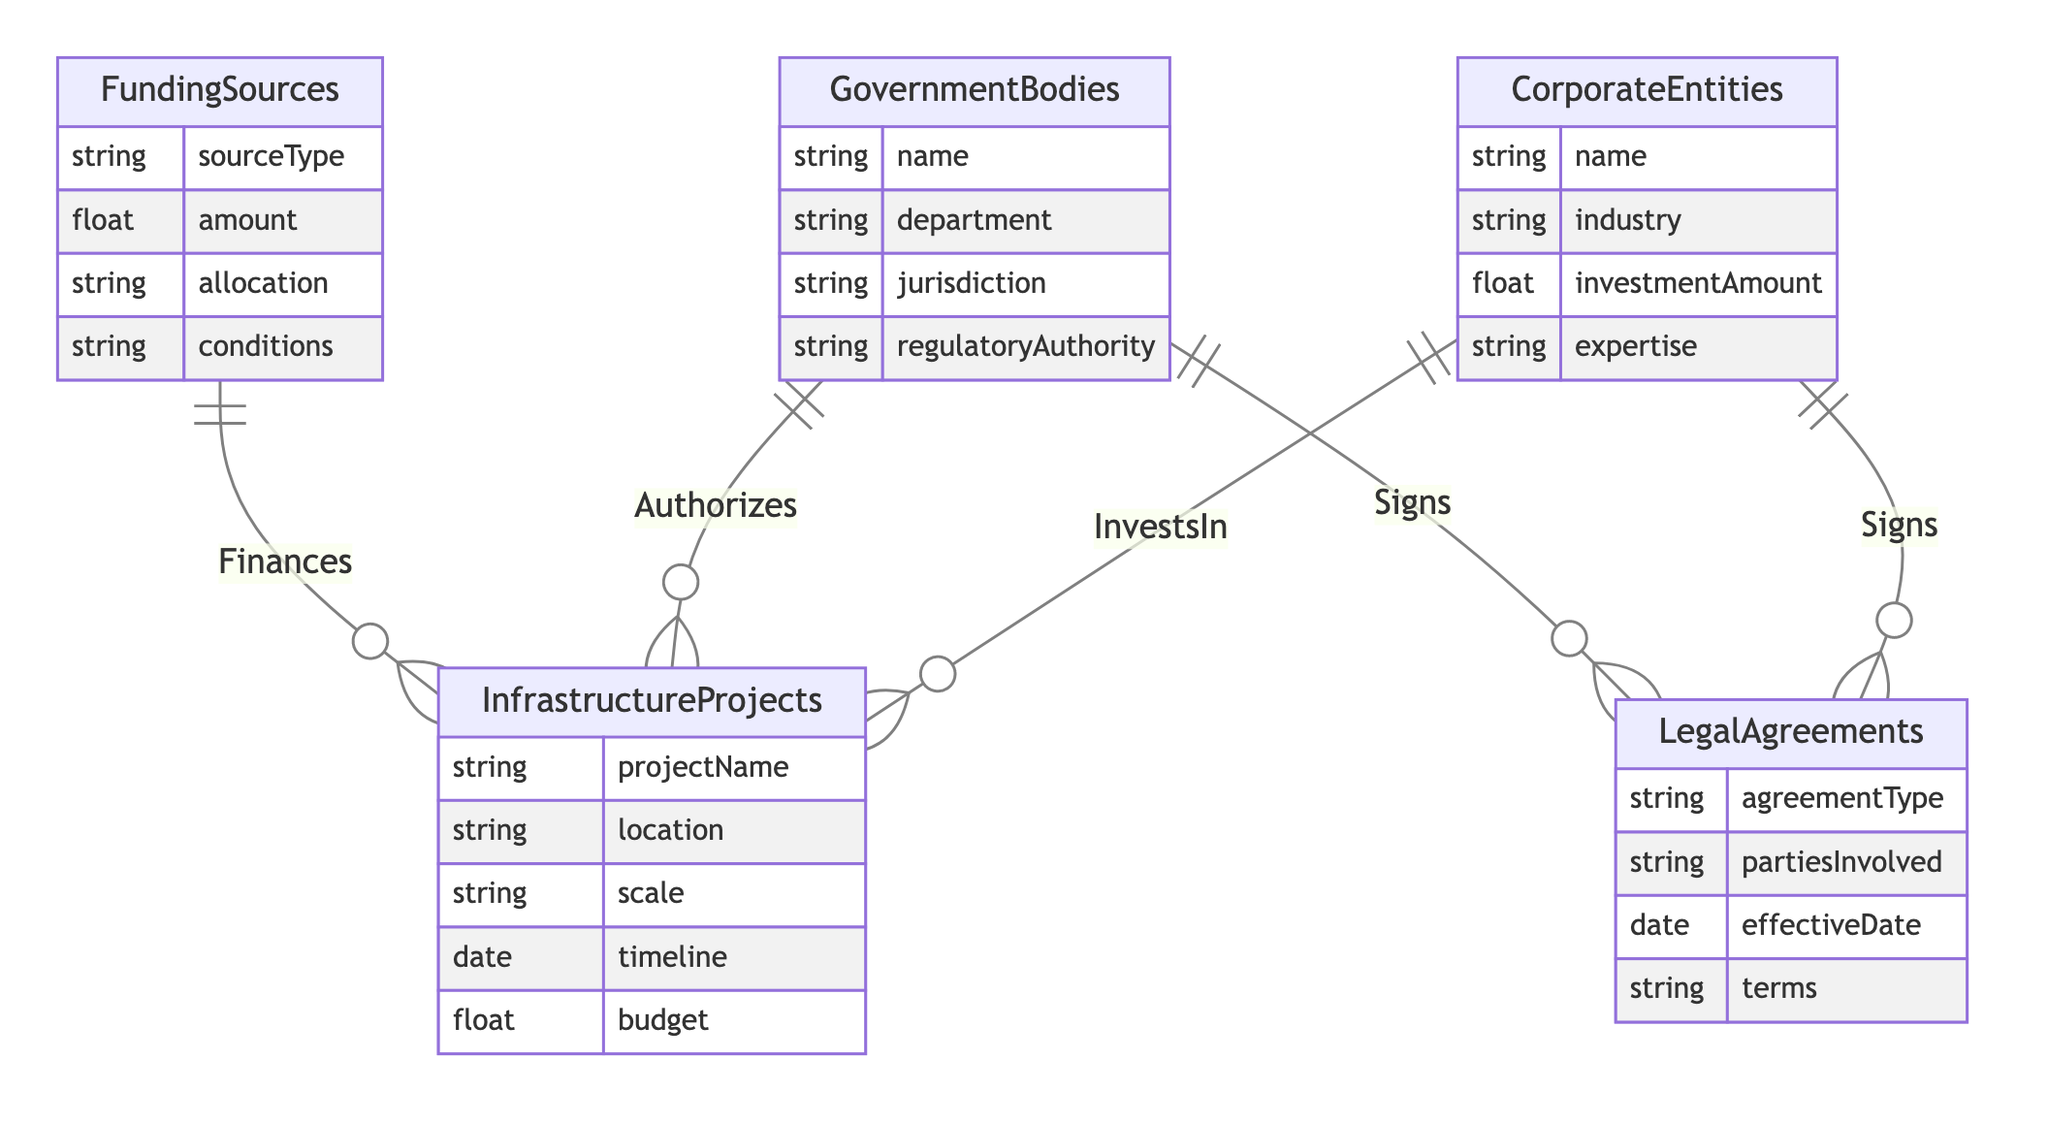What entities are involved in this diagram? The diagram includes five entities: Corporate Entities, Government Bodies, Funding Sources, Infrastructure Projects, and Legal Agreements. Each of these represents a fundamental aspect of public-private partnerships.
Answer: Corporate Entities, Government Bodies, Funding Sources, Infrastructure Projects, Legal Agreements How many relationships are depicted in the diagram? The diagram shows five relationships between the entities: invests in, authorizes, finances, and signs. Each pair of entities has a defined connection, illustrating their interactions.
Answer: Five What type of relationship connects Corporate Entities and Infrastructure Projects? The relationship connects Corporate Entities and Infrastructure Projects through "Invests In", indicating that Corporate Entities provide financial resources for these projects.
Answer: Invests In Which entities sign Legal Agreements? Both Corporate Entities and Government Bodies are involved in signing Legal Agreements, as indicated by separate relationships labeled "Signs." This reflects their participation in formal contracts related to projects.
Answer: Corporate Entities, Government Bodies What attributes are associated with Government Bodies? Government Bodies have the following attributes: name, department, jurisdiction, and regulatory authority. These attributes describe the characteristics and functions of each government entity involved in the partnership.
Answer: name, department, jurisdiction, regulatory authority How do Funding Sources relate to Infrastructure Projects? Funding Sources have a "Finances" relationship with Infrastructure Projects, indicating that they provide monetary support to these initiatives, specifying the amount and schedule for disbursement.
Answer: Finances Which entity authorizes Infrastructure Projects? Government Bodies are responsible for authorizing Infrastructure Projects, which is a key component of ensuring that projects comply with regulations and standards set by governmental authorities.
Answer: Government Bodies What is a potential condition for Funding Sources? The conditions attribute associated with Funding Sources could relate to stipulations that dictate how funding must be used or what criteria must be met for disbursement, although specific examples aren't provided in the diagram.
Answer: conditions Which relationship indicates investment by Corporate Entities? The relationship that indicates investment by Corporate Entities is labeled "Invests In," specifying their role in financial contributions to the Infrastructure Projects.
Answer: Invests In 